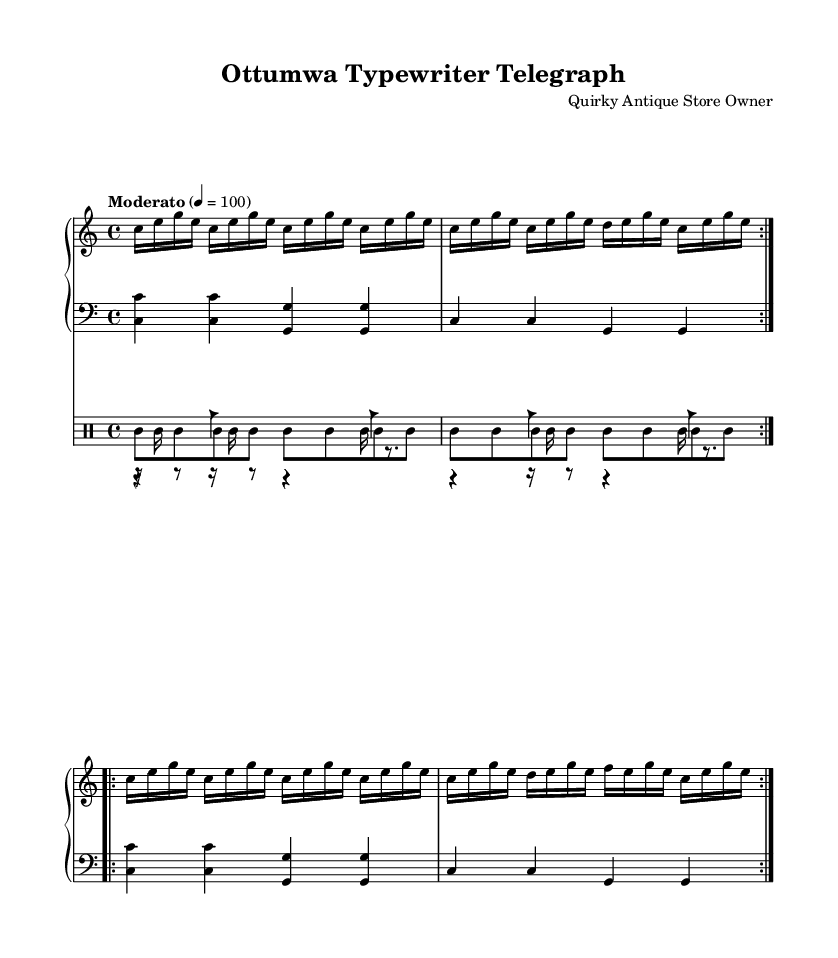What is the key signature of this music? The key signature is indicated at the beginning of the score. Looking at the sheet music, there are no sharps or flats shown in the key signature, which designates it as C major.
Answer: C major What is the time signature of this composition? The time signature is found right after the key signature at the beginning of the score. It is shown as 4/4, indicating four beats in each measure.
Answer: 4/4 What is the tempo marking of this piece? The tempo is given in a textual form at the beginning of the piece. The indication "Moderato" suggests a moderate pace, and the numbers indicate a specific metronome marking of 100 beats per minute.
Answer: Moderato 4 = 100 How many measures are used in the right hand section? By counting the measures in the right hand part, we note that there are 8 measures in total, as shown by the formatting and repeats within the section.
Answer: 8 What rhythmic instrument is used to play the woodblock pattern? The use of "wbh" in the drum notation within the score clearly indicates that the woodblock is the instrument responsible for that rhythm.
Answer: Woodblock Why do you think the composer chose to use a cowbell rhythm in this composition? Analyzing the components of the music, the cowbell adds a percussive, vintage texture that mimics the mechanical sounds of typewriters and telegraph machines. This reflects the intended theme and atmosphere of the piece.
Answer: Reflects vintage theme What is the function of the tambourine in the overall composition? The tambourine is utilized traditionally for its bright, jingly sound which adds an additional layer of rhythm and keeps the tempo energetic. Its rhythm pattern complements the other percussion instruments, enhancing the piece’s lively feel.
Answer: Complements rhythm 